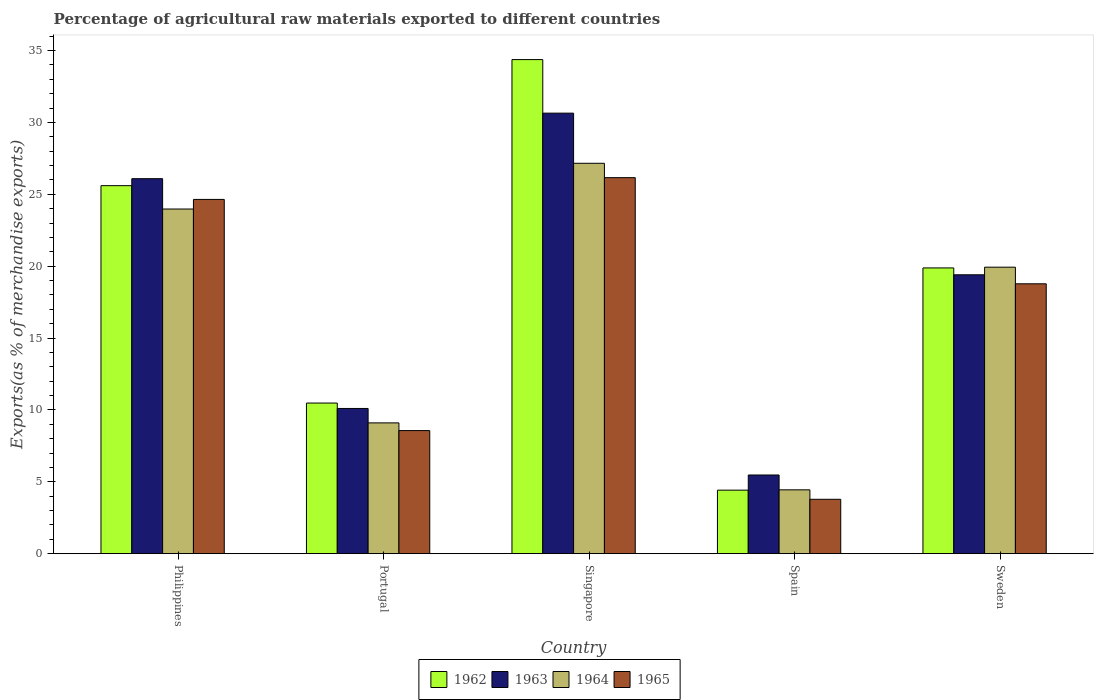How many different coloured bars are there?
Your answer should be compact. 4. How many groups of bars are there?
Keep it short and to the point. 5. Are the number of bars on each tick of the X-axis equal?
Your answer should be very brief. Yes. How many bars are there on the 3rd tick from the left?
Give a very brief answer. 4. How many bars are there on the 2nd tick from the right?
Make the answer very short. 4. What is the label of the 5th group of bars from the left?
Make the answer very short. Sweden. In how many cases, is the number of bars for a given country not equal to the number of legend labels?
Your answer should be very brief. 0. What is the percentage of exports to different countries in 1964 in Spain?
Ensure brevity in your answer.  4.44. Across all countries, what is the maximum percentage of exports to different countries in 1964?
Keep it short and to the point. 27.16. Across all countries, what is the minimum percentage of exports to different countries in 1964?
Make the answer very short. 4.44. In which country was the percentage of exports to different countries in 1965 maximum?
Offer a terse response. Singapore. What is the total percentage of exports to different countries in 1965 in the graph?
Offer a very short reply. 81.93. What is the difference between the percentage of exports to different countries in 1964 in Singapore and that in Sweden?
Your answer should be compact. 7.23. What is the difference between the percentage of exports to different countries in 1965 in Portugal and the percentage of exports to different countries in 1963 in Singapore?
Offer a terse response. -22.09. What is the average percentage of exports to different countries in 1962 per country?
Give a very brief answer. 18.95. What is the difference between the percentage of exports to different countries of/in 1963 and percentage of exports to different countries of/in 1965 in Sweden?
Offer a terse response. 0.63. What is the ratio of the percentage of exports to different countries in 1964 in Spain to that in Sweden?
Your answer should be very brief. 0.22. Is the difference between the percentage of exports to different countries in 1963 in Philippines and Singapore greater than the difference between the percentage of exports to different countries in 1965 in Philippines and Singapore?
Your answer should be compact. No. What is the difference between the highest and the second highest percentage of exports to different countries in 1965?
Your answer should be very brief. -1.51. What is the difference between the highest and the lowest percentage of exports to different countries in 1963?
Your response must be concise. 25.18. In how many countries, is the percentage of exports to different countries in 1962 greater than the average percentage of exports to different countries in 1962 taken over all countries?
Offer a terse response. 3. What does the 3rd bar from the left in Portugal represents?
Your answer should be compact. 1964. What does the 3rd bar from the right in Sweden represents?
Offer a terse response. 1963. How many bars are there?
Your answer should be compact. 20. Are all the bars in the graph horizontal?
Provide a succinct answer. No. How many countries are there in the graph?
Provide a succinct answer. 5. What is the difference between two consecutive major ticks on the Y-axis?
Provide a succinct answer. 5. Does the graph contain any zero values?
Give a very brief answer. No. Does the graph contain grids?
Your answer should be compact. No. How many legend labels are there?
Your answer should be very brief. 4. What is the title of the graph?
Give a very brief answer. Percentage of agricultural raw materials exported to different countries. Does "1978" appear as one of the legend labels in the graph?
Provide a short and direct response. No. What is the label or title of the X-axis?
Make the answer very short. Country. What is the label or title of the Y-axis?
Offer a very short reply. Exports(as % of merchandise exports). What is the Exports(as % of merchandise exports) of 1962 in Philippines?
Ensure brevity in your answer.  25.6. What is the Exports(as % of merchandise exports) in 1963 in Philippines?
Your response must be concise. 26.09. What is the Exports(as % of merchandise exports) of 1964 in Philippines?
Provide a short and direct response. 23.98. What is the Exports(as % of merchandise exports) of 1965 in Philippines?
Your answer should be compact. 24.65. What is the Exports(as % of merchandise exports) in 1962 in Portugal?
Offer a terse response. 10.48. What is the Exports(as % of merchandise exports) of 1963 in Portugal?
Provide a succinct answer. 10.1. What is the Exports(as % of merchandise exports) of 1964 in Portugal?
Give a very brief answer. 9.1. What is the Exports(as % of merchandise exports) in 1965 in Portugal?
Offer a very short reply. 8.56. What is the Exports(as % of merchandise exports) in 1962 in Singapore?
Offer a terse response. 34.38. What is the Exports(as % of merchandise exports) in 1963 in Singapore?
Offer a terse response. 30.65. What is the Exports(as % of merchandise exports) of 1964 in Singapore?
Provide a succinct answer. 27.16. What is the Exports(as % of merchandise exports) of 1965 in Singapore?
Your answer should be compact. 26.16. What is the Exports(as % of merchandise exports) of 1962 in Spain?
Your response must be concise. 4.42. What is the Exports(as % of merchandise exports) of 1963 in Spain?
Give a very brief answer. 5.47. What is the Exports(as % of merchandise exports) of 1964 in Spain?
Ensure brevity in your answer.  4.44. What is the Exports(as % of merchandise exports) in 1965 in Spain?
Provide a succinct answer. 3.78. What is the Exports(as % of merchandise exports) in 1962 in Sweden?
Ensure brevity in your answer.  19.88. What is the Exports(as % of merchandise exports) of 1963 in Sweden?
Provide a succinct answer. 19.4. What is the Exports(as % of merchandise exports) of 1964 in Sweden?
Provide a succinct answer. 19.93. What is the Exports(as % of merchandise exports) in 1965 in Sweden?
Provide a short and direct response. 18.78. Across all countries, what is the maximum Exports(as % of merchandise exports) of 1962?
Provide a succinct answer. 34.38. Across all countries, what is the maximum Exports(as % of merchandise exports) of 1963?
Provide a short and direct response. 30.65. Across all countries, what is the maximum Exports(as % of merchandise exports) in 1964?
Keep it short and to the point. 27.16. Across all countries, what is the maximum Exports(as % of merchandise exports) of 1965?
Provide a short and direct response. 26.16. Across all countries, what is the minimum Exports(as % of merchandise exports) of 1962?
Offer a very short reply. 4.42. Across all countries, what is the minimum Exports(as % of merchandise exports) in 1963?
Provide a succinct answer. 5.47. Across all countries, what is the minimum Exports(as % of merchandise exports) in 1964?
Your answer should be very brief. 4.44. Across all countries, what is the minimum Exports(as % of merchandise exports) in 1965?
Ensure brevity in your answer.  3.78. What is the total Exports(as % of merchandise exports) of 1962 in the graph?
Provide a short and direct response. 94.76. What is the total Exports(as % of merchandise exports) of 1963 in the graph?
Make the answer very short. 91.72. What is the total Exports(as % of merchandise exports) in 1964 in the graph?
Your answer should be very brief. 84.61. What is the total Exports(as % of merchandise exports) in 1965 in the graph?
Offer a terse response. 81.93. What is the difference between the Exports(as % of merchandise exports) in 1962 in Philippines and that in Portugal?
Your answer should be compact. 15.13. What is the difference between the Exports(as % of merchandise exports) in 1963 in Philippines and that in Portugal?
Provide a short and direct response. 15.99. What is the difference between the Exports(as % of merchandise exports) in 1964 in Philippines and that in Portugal?
Your response must be concise. 14.88. What is the difference between the Exports(as % of merchandise exports) of 1965 in Philippines and that in Portugal?
Provide a succinct answer. 16.08. What is the difference between the Exports(as % of merchandise exports) of 1962 in Philippines and that in Singapore?
Make the answer very short. -8.77. What is the difference between the Exports(as % of merchandise exports) of 1963 in Philippines and that in Singapore?
Your answer should be compact. -4.56. What is the difference between the Exports(as % of merchandise exports) in 1964 in Philippines and that in Singapore?
Give a very brief answer. -3.18. What is the difference between the Exports(as % of merchandise exports) in 1965 in Philippines and that in Singapore?
Give a very brief answer. -1.51. What is the difference between the Exports(as % of merchandise exports) in 1962 in Philippines and that in Spain?
Give a very brief answer. 21.19. What is the difference between the Exports(as % of merchandise exports) in 1963 in Philippines and that in Spain?
Your answer should be very brief. 20.62. What is the difference between the Exports(as % of merchandise exports) in 1964 in Philippines and that in Spain?
Make the answer very short. 19.54. What is the difference between the Exports(as % of merchandise exports) in 1965 in Philippines and that in Spain?
Make the answer very short. 20.86. What is the difference between the Exports(as % of merchandise exports) in 1962 in Philippines and that in Sweden?
Ensure brevity in your answer.  5.72. What is the difference between the Exports(as % of merchandise exports) in 1963 in Philippines and that in Sweden?
Offer a very short reply. 6.69. What is the difference between the Exports(as % of merchandise exports) in 1964 in Philippines and that in Sweden?
Your response must be concise. 4.05. What is the difference between the Exports(as % of merchandise exports) of 1965 in Philippines and that in Sweden?
Keep it short and to the point. 5.87. What is the difference between the Exports(as % of merchandise exports) in 1962 in Portugal and that in Singapore?
Your response must be concise. -23.9. What is the difference between the Exports(as % of merchandise exports) of 1963 in Portugal and that in Singapore?
Ensure brevity in your answer.  -20.55. What is the difference between the Exports(as % of merchandise exports) in 1964 in Portugal and that in Singapore?
Your answer should be very brief. -18.06. What is the difference between the Exports(as % of merchandise exports) of 1965 in Portugal and that in Singapore?
Make the answer very short. -17.6. What is the difference between the Exports(as % of merchandise exports) in 1962 in Portugal and that in Spain?
Your answer should be compact. 6.06. What is the difference between the Exports(as % of merchandise exports) in 1963 in Portugal and that in Spain?
Provide a succinct answer. 4.63. What is the difference between the Exports(as % of merchandise exports) in 1964 in Portugal and that in Spain?
Provide a succinct answer. 4.66. What is the difference between the Exports(as % of merchandise exports) of 1965 in Portugal and that in Spain?
Give a very brief answer. 4.78. What is the difference between the Exports(as % of merchandise exports) in 1962 in Portugal and that in Sweden?
Provide a succinct answer. -9.4. What is the difference between the Exports(as % of merchandise exports) in 1963 in Portugal and that in Sweden?
Your answer should be compact. -9.3. What is the difference between the Exports(as % of merchandise exports) in 1964 in Portugal and that in Sweden?
Offer a very short reply. -10.83. What is the difference between the Exports(as % of merchandise exports) of 1965 in Portugal and that in Sweden?
Make the answer very short. -10.21. What is the difference between the Exports(as % of merchandise exports) in 1962 in Singapore and that in Spain?
Make the answer very short. 29.96. What is the difference between the Exports(as % of merchandise exports) in 1963 in Singapore and that in Spain?
Your answer should be very brief. 25.18. What is the difference between the Exports(as % of merchandise exports) of 1964 in Singapore and that in Spain?
Offer a terse response. 22.72. What is the difference between the Exports(as % of merchandise exports) in 1965 in Singapore and that in Spain?
Offer a very short reply. 22.38. What is the difference between the Exports(as % of merchandise exports) in 1962 in Singapore and that in Sweden?
Offer a very short reply. 14.5. What is the difference between the Exports(as % of merchandise exports) in 1963 in Singapore and that in Sweden?
Offer a very short reply. 11.25. What is the difference between the Exports(as % of merchandise exports) of 1964 in Singapore and that in Sweden?
Keep it short and to the point. 7.23. What is the difference between the Exports(as % of merchandise exports) in 1965 in Singapore and that in Sweden?
Give a very brief answer. 7.39. What is the difference between the Exports(as % of merchandise exports) in 1962 in Spain and that in Sweden?
Offer a terse response. -15.46. What is the difference between the Exports(as % of merchandise exports) in 1963 in Spain and that in Sweden?
Offer a very short reply. -13.93. What is the difference between the Exports(as % of merchandise exports) in 1964 in Spain and that in Sweden?
Your answer should be very brief. -15.49. What is the difference between the Exports(as % of merchandise exports) in 1965 in Spain and that in Sweden?
Ensure brevity in your answer.  -14.99. What is the difference between the Exports(as % of merchandise exports) in 1962 in Philippines and the Exports(as % of merchandise exports) in 1963 in Portugal?
Your response must be concise. 15.5. What is the difference between the Exports(as % of merchandise exports) of 1962 in Philippines and the Exports(as % of merchandise exports) of 1964 in Portugal?
Offer a terse response. 16.5. What is the difference between the Exports(as % of merchandise exports) in 1962 in Philippines and the Exports(as % of merchandise exports) in 1965 in Portugal?
Ensure brevity in your answer.  17.04. What is the difference between the Exports(as % of merchandise exports) in 1963 in Philippines and the Exports(as % of merchandise exports) in 1964 in Portugal?
Ensure brevity in your answer.  16.99. What is the difference between the Exports(as % of merchandise exports) in 1963 in Philippines and the Exports(as % of merchandise exports) in 1965 in Portugal?
Ensure brevity in your answer.  17.53. What is the difference between the Exports(as % of merchandise exports) in 1964 in Philippines and the Exports(as % of merchandise exports) in 1965 in Portugal?
Your answer should be very brief. 15.42. What is the difference between the Exports(as % of merchandise exports) in 1962 in Philippines and the Exports(as % of merchandise exports) in 1963 in Singapore?
Give a very brief answer. -5.04. What is the difference between the Exports(as % of merchandise exports) of 1962 in Philippines and the Exports(as % of merchandise exports) of 1964 in Singapore?
Offer a terse response. -1.56. What is the difference between the Exports(as % of merchandise exports) in 1962 in Philippines and the Exports(as % of merchandise exports) in 1965 in Singapore?
Provide a succinct answer. -0.56. What is the difference between the Exports(as % of merchandise exports) of 1963 in Philippines and the Exports(as % of merchandise exports) of 1964 in Singapore?
Provide a succinct answer. -1.07. What is the difference between the Exports(as % of merchandise exports) of 1963 in Philippines and the Exports(as % of merchandise exports) of 1965 in Singapore?
Provide a short and direct response. -0.07. What is the difference between the Exports(as % of merchandise exports) of 1964 in Philippines and the Exports(as % of merchandise exports) of 1965 in Singapore?
Make the answer very short. -2.18. What is the difference between the Exports(as % of merchandise exports) in 1962 in Philippines and the Exports(as % of merchandise exports) in 1963 in Spain?
Make the answer very short. 20.13. What is the difference between the Exports(as % of merchandise exports) in 1962 in Philippines and the Exports(as % of merchandise exports) in 1964 in Spain?
Provide a short and direct response. 21.16. What is the difference between the Exports(as % of merchandise exports) in 1962 in Philippines and the Exports(as % of merchandise exports) in 1965 in Spain?
Your answer should be very brief. 21.82. What is the difference between the Exports(as % of merchandise exports) in 1963 in Philippines and the Exports(as % of merchandise exports) in 1964 in Spain?
Keep it short and to the point. 21.65. What is the difference between the Exports(as % of merchandise exports) of 1963 in Philippines and the Exports(as % of merchandise exports) of 1965 in Spain?
Give a very brief answer. 22.31. What is the difference between the Exports(as % of merchandise exports) in 1964 in Philippines and the Exports(as % of merchandise exports) in 1965 in Spain?
Your answer should be compact. 20.2. What is the difference between the Exports(as % of merchandise exports) of 1962 in Philippines and the Exports(as % of merchandise exports) of 1963 in Sweden?
Make the answer very short. 6.2. What is the difference between the Exports(as % of merchandise exports) in 1962 in Philippines and the Exports(as % of merchandise exports) in 1964 in Sweden?
Offer a very short reply. 5.67. What is the difference between the Exports(as % of merchandise exports) of 1962 in Philippines and the Exports(as % of merchandise exports) of 1965 in Sweden?
Offer a very short reply. 6.83. What is the difference between the Exports(as % of merchandise exports) of 1963 in Philippines and the Exports(as % of merchandise exports) of 1964 in Sweden?
Give a very brief answer. 6.16. What is the difference between the Exports(as % of merchandise exports) of 1963 in Philippines and the Exports(as % of merchandise exports) of 1965 in Sweden?
Your answer should be compact. 7.31. What is the difference between the Exports(as % of merchandise exports) of 1964 in Philippines and the Exports(as % of merchandise exports) of 1965 in Sweden?
Make the answer very short. 5.2. What is the difference between the Exports(as % of merchandise exports) of 1962 in Portugal and the Exports(as % of merchandise exports) of 1963 in Singapore?
Provide a short and direct response. -20.17. What is the difference between the Exports(as % of merchandise exports) of 1962 in Portugal and the Exports(as % of merchandise exports) of 1964 in Singapore?
Ensure brevity in your answer.  -16.68. What is the difference between the Exports(as % of merchandise exports) of 1962 in Portugal and the Exports(as % of merchandise exports) of 1965 in Singapore?
Provide a short and direct response. -15.68. What is the difference between the Exports(as % of merchandise exports) of 1963 in Portugal and the Exports(as % of merchandise exports) of 1964 in Singapore?
Make the answer very short. -17.06. What is the difference between the Exports(as % of merchandise exports) of 1963 in Portugal and the Exports(as % of merchandise exports) of 1965 in Singapore?
Ensure brevity in your answer.  -16.06. What is the difference between the Exports(as % of merchandise exports) in 1964 in Portugal and the Exports(as % of merchandise exports) in 1965 in Singapore?
Offer a very short reply. -17.06. What is the difference between the Exports(as % of merchandise exports) of 1962 in Portugal and the Exports(as % of merchandise exports) of 1963 in Spain?
Offer a terse response. 5. What is the difference between the Exports(as % of merchandise exports) of 1962 in Portugal and the Exports(as % of merchandise exports) of 1964 in Spain?
Your answer should be compact. 6.04. What is the difference between the Exports(as % of merchandise exports) in 1962 in Portugal and the Exports(as % of merchandise exports) in 1965 in Spain?
Your answer should be very brief. 6.7. What is the difference between the Exports(as % of merchandise exports) in 1963 in Portugal and the Exports(as % of merchandise exports) in 1964 in Spain?
Your answer should be compact. 5.66. What is the difference between the Exports(as % of merchandise exports) of 1963 in Portugal and the Exports(as % of merchandise exports) of 1965 in Spain?
Your answer should be compact. 6.32. What is the difference between the Exports(as % of merchandise exports) in 1964 in Portugal and the Exports(as % of merchandise exports) in 1965 in Spain?
Provide a succinct answer. 5.32. What is the difference between the Exports(as % of merchandise exports) of 1962 in Portugal and the Exports(as % of merchandise exports) of 1963 in Sweden?
Provide a succinct answer. -8.92. What is the difference between the Exports(as % of merchandise exports) of 1962 in Portugal and the Exports(as % of merchandise exports) of 1964 in Sweden?
Keep it short and to the point. -9.45. What is the difference between the Exports(as % of merchandise exports) of 1962 in Portugal and the Exports(as % of merchandise exports) of 1965 in Sweden?
Provide a short and direct response. -8.3. What is the difference between the Exports(as % of merchandise exports) in 1963 in Portugal and the Exports(as % of merchandise exports) in 1964 in Sweden?
Provide a succinct answer. -9.83. What is the difference between the Exports(as % of merchandise exports) of 1963 in Portugal and the Exports(as % of merchandise exports) of 1965 in Sweden?
Keep it short and to the point. -8.67. What is the difference between the Exports(as % of merchandise exports) in 1964 in Portugal and the Exports(as % of merchandise exports) in 1965 in Sweden?
Provide a succinct answer. -9.68. What is the difference between the Exports(as % of merchandise exports) of 1962 in Singapore and the Exports(as % of merchandise exports) of 1963 in Spain?
Offer a very short reply. 28.9. What is the difference between the Exports(as % of merchandise exports) in 1962 in Singapore and the Exports(as % of merchandise exports) in 1964 in Spain?
Your answer should be compact. 29.94. What is the difference between the Exports(as % of merchandise exports) of 1962 in Singapore and the Exports(as % of merchandise exports) of 1965 in Spain?
Provide a short and direct response. 30.59. What is the difference between the Exports(as % of merchandise exports) of 1963 in Singapore and the Exports(as % of merchandise exports) of 1964 in Spain?
Offer a terse response. 26.21. What is the difference between the Exports(as % of merchandise exports) in 1963 in Singapore and the Exports(as % of merchandise exports) in 1965 in Spain?
Your answer should be compact. 26.87. What is the difference between the Exports(as % of merchandise exports) in 1964 in Singapore and the Exports(as % of merchandise exports) in 1965 in Spain?
Make the answer very short. 23.38. What is the difference between the Exports(as % of merchandise exports) in 1962 in Singapore and the Exports(as % of merchandise exports) in 1963 in Sweden?
Ensure brevity in your answer.  14.97. What is the difference between the Exports(as % of merchandise exports) of 1962 in Singapore and the Exports(as % of merchandise exports) of 1964 in Sweden?
Ensure brevity in your answer.  14.44. What is the difference between the Exports(as % of merchandise exports) of 1962 in Singapore and the Exports(as % of merchandise exports) of 1965 in Sweden?
Give a very brief answer. 15.6. What is the difference between the Exports(as % of merchandise exports) in 1963 in Singapore and the Exports(as % of merchandise exports) in 1964 in Sweden?
Ensure brevity in your answer.  10.72. What is the difference between the Exports(as % of merchandise exports) in 1963 in Singapore and the Exports(as % of merchandise exports) in 1965 in Sweden?
Provide a short and direct response. 11.87. What is the difference between the Exports(as % of merchandise exports) of 1964 in Singapore and the Exports(as % of merchandise exports) of 1965 in Sweden?
Your response must be concise. 8.39. What is the difference between the Exports(as % of merchandise exports) of 1962 in Spain and the Exports(as % of merchandise exports) of 1963 in Sweden?
Provide a succinct answer. -14.98. What is the difference between the Exports(as % of merchandise exports) in 1962 in Spain and the Exports(as % of merchandise exports) in 1964 in Sweden?
Your answer should be very brief. -15.51. What is the difference between the Exports(as % of merchandise exports) of 1962 in Spain and the Exports(as % of merchandise exports) of 1965 in Sweden?
Ensure brevity in your answer.  -14.36. What is the difference between the Exports(as % of merchandise exports) in 1963 in Spain and the Exports(as % of merchandise exports) in 1964 in Sweden?
Give a very brief answer. -14.46. What is the difference between the Exports(as % of merchandise exports) in 1963 in Spain and the Exports(as % of merchandise exports) in 1965 in Sweden?
Ensure brevity in your answer.  -13.3. What is the difference between the Exports(as % of merchandise exports) in 1964 in Spain and the Exports(as % of merchandise exports) in 1965 in Sweden?
Your response must be concise. -14.33. What is the average Exports(as % of merchandise exports) in 1962 per country?
Ensure brevity in your answer.  18.95. What is the average Exports(as % of merchandise exports) in 1963 per country?
Your answer should be very brief. 18.34. What is the average Exports(as % of merchandise exports) in 1964 per country?
Keep it short and to the point. 16.92. What is the average Exports(as % of merchandise exports) of 1965 per country?
Provide a succinct answer. 16.39. What is the difference between the Exports(as % of merchandise exports) of 1962 and Exports(as % of merchandise exports) of 1963 in Philippines?
Keep it short and to the point. -0.49. What is the difference between the Exports(as % of merchandise exports) in 1962 and Exports(as % of merchandise exports) in 1964 in Philippines?
Provide a short and direct response. 1.63. What is the difference between the Exports(as % of merchandise exports) of 1962 and Exports(as % of merchandise exports) of 1965 in Philippines?
Offer a terse response. 0.96. What is the difference between the Exports(as % of merchandise exports) of 1963 and Exports(as % of merchandise exports) of 1964 in Philippines?
Provide a succinct answer. 2.11. What is the difference between the Exports(as % of merchandise exports) of 1963 and Exports(as % of merchandise exports) of 1965 in Philippines?
Provide a succinct answer. 1.44. What is the difference between the Exports(as % of merchandise exports) of 1964 and Exports(as % of merchandise exports) of 1965 in Philippines?
Provide a succinct answer. -0.67. What is the difference between the Exports(as % of merchandise exports) of 1962 and Exports(as % of merchandise exports) of 1963 in Portugal?
Your response must be concise. 0.38. What is the difference between the Exports(as % of merchandise exports) in 1962 and Exports(as % of merchandise exports) in 1964 in Portugal?
Make the answer very short. 1.38. What is the difference between the Exports(as % of merchandise exports) in 1962 and Exports(as % of merchandise exports) in 1965 in Portugal?
Your answer should be very brief. 1.92. What is the difference between the Exports(as % of merchandise exports) in 1963 and Exports(as % of merchandise exports) in 1965 in Portugal?
Offer a terse response. 1.54. What is the difference between the Exports(as % of merchandise exports) in 1964 and Exports(as % of merchandise exports) in 1965 in Portugal?
Provide a succinct answer. 0.54. What is the difference between the Exports(as % of merchandise exports) in 1962 and Exports(as % of merchandise exports) in 1963 in Singapore?
Offer a terse response. 3.73. What is the difference between the Exports(as % of merchandise exports) of 1962 and Exports(as % of merchandise exports) of 1964 in Singapore?
Keep it short and to the point. 7.22. What is the difference between the Exports(as % of merchandise exports) of 1962 and Exports(as % of merchandise exports) of 1965 in Singapore?
Provide a succinct answer. 8.22. What is the difference between the Exports(as % of merchandise exports) of 1963 and Exports(as % of merchandise exports) of 1964 in Singapore?
Give a very brief answer. 3.49. What is the difference between the Exports(as % of merchandise exports) in 1963 and Exports(as % of merchandise exports) in 1965 in Singapore?
Give a very brief answer. 4.49. What is the difference between the Exports(as % of merchandise exports) in 1964 and Exports(as % of merchandise exports) in 1965 in Singapore?
Offer a terse response. 1. What is the difference between the Exports(as % of merchandise exports) of 1962 and Exports(as % of merchandise exports) of 1963 in Spain?
Your response must be concise. -1.06. What is the difference between the Exports(as % of merchandise exports) in 1962 and Exports(as % of merchandise exports) in 1964 in Spain?
Provide a short and direct response. -0.02. What is the difference between the Exports(as % of merchandise exports) in 1962 and Exports(as % of merchandise exports) in 1965 in Spain?
Give a very brief answer. 0.64. What is the difference between the Exports(as % of merchandise exports) in 1963 and Exports(as % of merchandise exports) in 1964 in Spain?
Your response must be concise. 1.03. What is the difference between the Exports(as % of merchandise exports) of 1963 and Exports(as % of merchandise exports) of 1965 in Spain?
Make the answer very short. 1.69. What is the difference between the Exports(as % of merchandise exports) of 1964 and Exports(as % of merchandise exports) of 1965 in Spain?
Ensure brevity in your answer.  0.66. What is the difference between the Exports(as % of merchandise exports) in 1962 and Exports(as % of merchandise exports) in 1963 in Sweden?
Offer a terse response. 0.48. What is the difference between the Exports(as % of merchandise exports) in 1962 and Exports(as % of merchandise exports) in 1964 in Sweden?
Your answer should be very brief. -0.05. What is the difference between the Exports(as % of merchandise exports) of 1962 and Exports(as % of merchandise exports) of 1965 in Sweden?
Provide a succinct answer. 1.1. What is the difference between the Exports(as % of merchandise exports) of 1963 and Exports(as % of merchandise exports) of 1964 in Sweden?
Make the answer very short. -0.53. What is the difference between the Exports(as % of merchandise exports) in 1963 and Exports(as % of merchandise exports) in 1965 in Sweden?
Your answer should be very brief. 0.63. What is the difference between the Exports(as % of merchandise exports) of 1964 and Exports(as % of merchandise exports) of 1965 in Sweden?
Give a very brief answer. 1.16. What is the ratio of the Exports(as % of merchandise exports) of 1962 in Philippines to that in Portugal?
Provide a succinct answer. 2.44. What is the ratio of the Exports(as % of merchandise exports) of 1963 in Philippines to that in Portugal?
Your answer should be very brief. 2.58. What is the ratio of the Exports(as % of merchandise exports) of 1964 in Philippines to that in Portugal?
Ensure brevity in your answer.  2.64. What is the ratio of the Exports(as % of merchandise exports) in 1965 in Philippines to that in Portugal?
Your response must be concise. 2.88. What is the ratio of the Exports(as % of merchandise exports) of 1962 in Philippines to that in Singapore?
Ensure brevity in your answer.  0.74. What is the ratio of the Exports(as % of merchandise exports) of 1963 in Philippines to that in Singapore?
Ensure brevity in your answer.  0.85. What is the ratio of the Exports(as % of merchandise exports) of 1964 in Philippines to that in Singapore?
Your answer should be compact. 0.88. What is the ratio of the Exports(as % of merchandise exports) in 1965 in Philippines to that in Singapore?
Offer a very short reply. 0.94. What is the ratio of the Exports(as % of merchandise exports) of 1962 in Philippines to that in Spain?
Your answer should be very brief. 5.79. What is the ratio of the Exports(as % of merchandise exports) in 1963 in Philippines to that in Spain?
Ensure brevity in your answer.  4.77. What is the ratio of the Exports(as % of merchandise exports) in 1964 in Philippines to that in Spain?
Offer a very short reply. 5.4. What is the ratio of the Exports(as % of merchandise exports) of 1965 in Philippines to that in Spain?
Make the answer very short. 6.52. What is the ratio of the Exports(as % of merchandise exports) in 1962 in Philippines to that in Sweden?
Provide a succinct answer. 1.29. What is the ratio of the Exports(as % of merchandise exports) in 1963 in Philippines to that in Sweden?
Give a very brief answer. 1.34. What is the ratio of the Exports(as % of merchandise exports) in 1964 in Philippines to that in Sweden?
Make the answer very short. 1.2. What is the ratio of the Exports(as % of merchandise exports) of 1965 in Philippines to that in Sweden?
Ensure brevity in your answer.  1.31. What is the ratio of the Exports(as % of merchandise exports) of 1962 in Portugal to that in Singapore?
Give a very brief answer. 0.3. What is the ratio of the Exports(as % of merchandise exports) in 1963 in Portugal to that in Singapore?
Offer a very short reply. 0.33. What is the ratio of the Exports(as % of merchandise exports) of 1964 in Portugal to that in Singapore?
Your answer should be compact. 0.34. What is the ratio of the Exports(as % of merchandise exports) in 1965 in Portugal to that in Singapore?
Your answer should be very brief. 0.33. What is the ratio of the Exports(as % of merchandise exports) of 1962 in Portugal to that in Spain?
Offer a very short reply. 2.37. What is the ratio of the Exports(as % of merchandise exports) in 1963 in Portugal to that in Spain?
Provide a succinct answer. 1.85. What is the ratio of the Exports(as % of merchandise exports) of 1964 in Portugal to that in Spain?
Your response must be concise. 2.05. What is the ratio of the Exports(as % of merchandise exports) in 1965 in Portugal to that in Spain?
Offer a terse response. 2.26. What is the ratio of the Exports(as % of merchandise exports) in 1962 in Portugal to that in Sweden?
Provide a succinct answer. 0.53. What is the ratio of the Exports(as % of merchandise exports) of 1963 in Portugal to that in Sweden?
Keep it short and to the point. 0.52. What is the ratio of the Exports(as % of merchandise exports) in 1964 in Portugal to that in Sweden?
Offer a terse response. 0.46. What is the ratio of the Exports(as % of merchandise exports) in 1965 in Portugal to that in Sweden?
Give a very brief answer. 0.46. What is the ratio of the Exports(as % of merchandise exports) of 1962 in Singapore to that in Spain?
Provide a succinct answer. 7.78. What is the ratio of the Exports(as % of merchandise exports) in 1963 in Singapore to that in Spain?
Your answer should be very brief. 5.6. What is the ratio of the Exports(as % of merchandise exports) of 1964 in Singapore to that in Spain?
Keep it short and to the point. 6.12. What is the ratio of the Exports(as % of merchandise exports) of 1965 in Singapore to that in Spain?
Ensure brevity in your answer.  6.92. What is the ratio of the Exports(as % of merchandise exports) in 1962 in Singapore to that in Sweden?
Your response must be concise. 1.73. What is the ratio of the Exports(as % of merchandise exports) in 1963 in Singapore to that in Sweden?
Keep it short and to the point. 1.58. What is the ratio of the Exports(as % of merchandise exports) in 1964 in Singapore to that in Sweden?
Keep it short and to the point. 1.36. What is the ratio of the Exports(as % of merchandise exports) of 1965 in Singapore to that in Sweden?
Provide a succinct answer. 1.39. What is the ratio of the Exports(as % of merchandise exports) in 1962 in Spain to that in Sweden?
Ensure brevity in your answer.  0.22. What is the ratio of the Exports(as % of merchandise exports) of 1963 in Spain to that in Sweden?
Your answer should be very brief. 0.28. What is the ratio of the Exports(as % of merchandise exports) in 1964 in Spain to that in Sweden?
Give a very brief answer. 0.22. What is the ratio of the Exports(as % of merchandise exports) in 1965 in Spain to that in Sweden?
Your answer should be very brief. 0.2. What is the difference between the highest and the second highest Exports(as % of merchandise exports) of 1962?
Your response must be concise. 8.77. What is the difference between the highest and the second highest Exports(as % of merchandise exports) in 1963?
Offer a very short reply. 4.56. What is the difference between the highest and the second highest Exports(as % of merchandise exports) in 1964?
Offer a very short reply. 3.18. What is the difference between the highest and the second highest Exports(as % of merchandise exports) in 1965?
Your answer should be very brief. 1.51. What is the difference between the highest and the lowest Exports(as % of merchandise exports) in 1962?
Keep it short and to the point. 29.96. What is the difference between the highest and the lowest Exports(as % of merchandise exports) of 1963?
Offer a terse response. 25.18. What is the difference between the highest and the lowest Exports(as % of merchandise exports) of 1964?
Your response must be concise. 22.72. What is the difference between the highest and the lowest Exports(as % of merchandise exports) of 1965?
Make the answer very short. 22.38. 